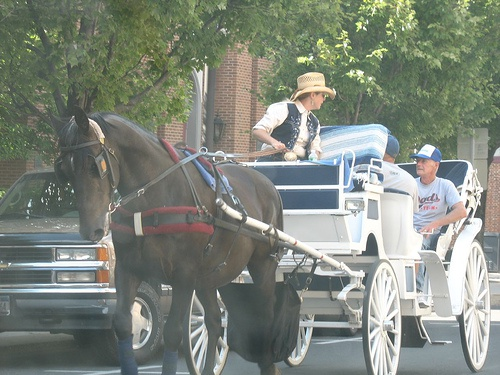Describe the objects in this image and their specific colors. I can see horse in gray tones, truck in gray, darkgray, and white tones, people in gray, ivory, darkgray, and tan tones, people in gray, lavender, darkgray, lightpink, and lightblue tones, and people in gray, lightgray, and darkgray tones in this image. 